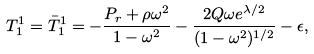<formula> <loc_0><loc_0><loc_500><loc_500>T ^ { 1 } _ { 1 } = \bar { T } ^ { 1 } _ { 1 } = - \frac { P _ { r } + \rho \omega ^ { 2 } } { 1 - \omega ^ { 2 } } - \frac { 2 Q \omega e ^ { \lambda / 2 } } { ( 1 - \omega ^ { 2 } ) ^ { 1 / 2 } } - \epsilon ,</formula> 